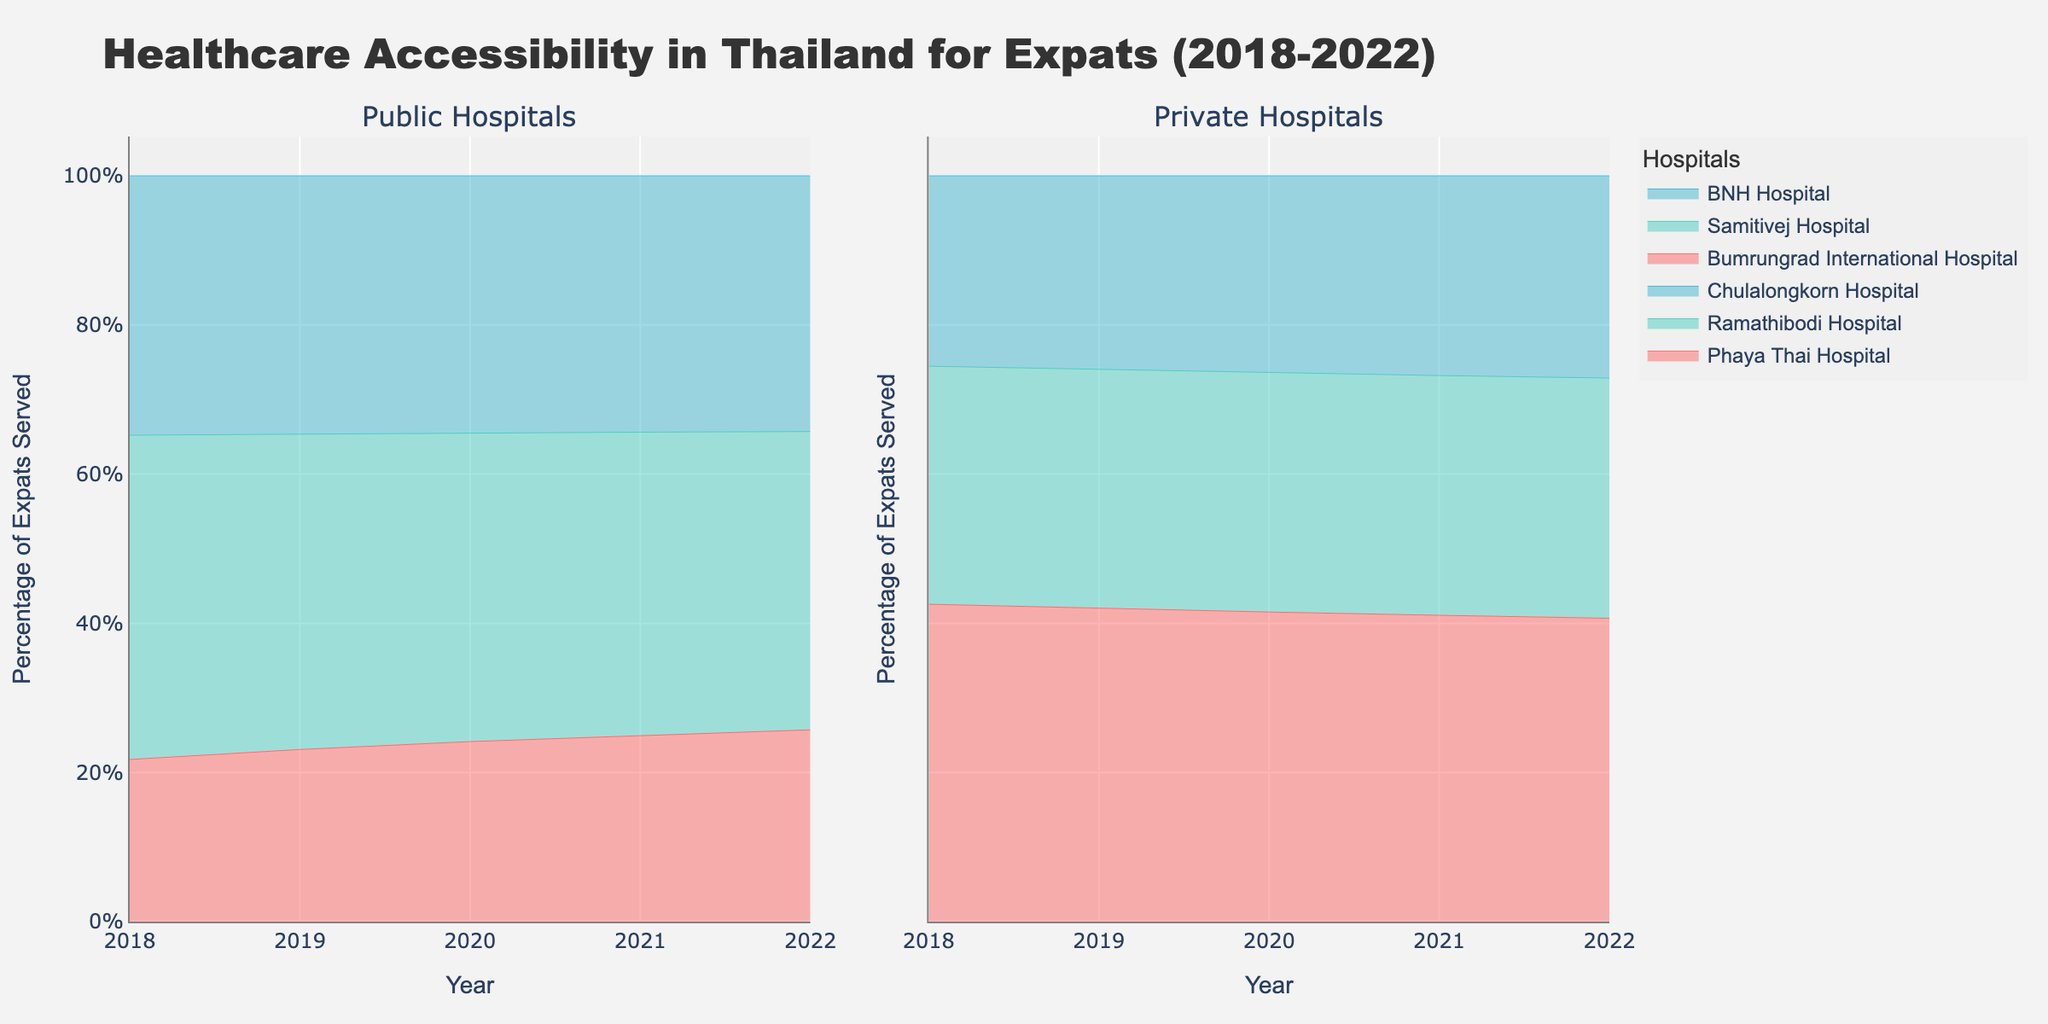What is the title of the figure? The title of the figure is located at the top and is in a larger font to attract attention. It reads, "Healthcare Accessibility in Thailand for Expats (2018-2022)".
Answer: Healthcare Accessibility in Thailand for Expats (2018-2022) What years are covered in the figure? The x-axes at the bottom of the plots show the range of years covered, starting from 2018 and ending in 2022.
Answer: 2018-2022 Which hospital served the highest percentage of expats in 2022 among private hospitals? By looking at the right subplot titled "Private Hospitals" and checking the data for 2022, it is evident that Bumrungrad International Hospital has the highest value.
Answer: Bumrungrad International Hospital What hospital had the lowest percentage of expats served in 2018 among public hospitals? In the left subplot titled "Public Hospitals", the 2018 data reveals that Phaya Thai Hospital has the lowest percentage value.
Answer: Phaya Thai Hospital How has the percentage of expats served by Ramathibodi Hospital changed from 2018 to 2022? From the public hospitals subplot, observe that the line for Ramathibodi Hospital increases from 10% in 2018 to 14% in 2022.
Answer: Increased by 4% Which service type (public or private) showed a more significant increase in the total percentage of expats served from 2018 to 2022? To assess this, observe the overall trend within each subplot. Both public and private hospitals show an increase, but private hospitals like Bumrungrad International Hospital show steep upward trends.
Answer: Private Which private hospital had the most notable growth over the five years? Within the private hospitals subplot, Bumrungrad International Hospital shows a continuous and notable rise in its percentage line from 20% in 2018 to 24% in 2022.
Answer: Bumrungrad International Hospital Compare the percentage of expats served by Samitivej Hospital in 2018 and 2020. How much did it increase? By looking at the line for Samitivej Hospital in the private hospitals subplot, it shows the percentage rising from 15% in 2018 to 17% in 2020.
Answer: Increased by 2% Are the percentages of expats served by private hospitals evenly spread among the three hospitals in any year? By observing the private hospitals subplot for each year, it can be noted that the percentages are not evenly spread in any particular year with Bumrungrad International Hospital consistently having the highest share.
Answer: No What is the main insight provided by the area charts regarding healthcare services usage by expats in Thailand? The area charts show an overall increase in the percentage of expats served by both public and private hospitals from 2018 to 2022, with a notable preference for private services, especially Bumrungrad International Hospital.
Answer: Increase in usage, preference for private services 